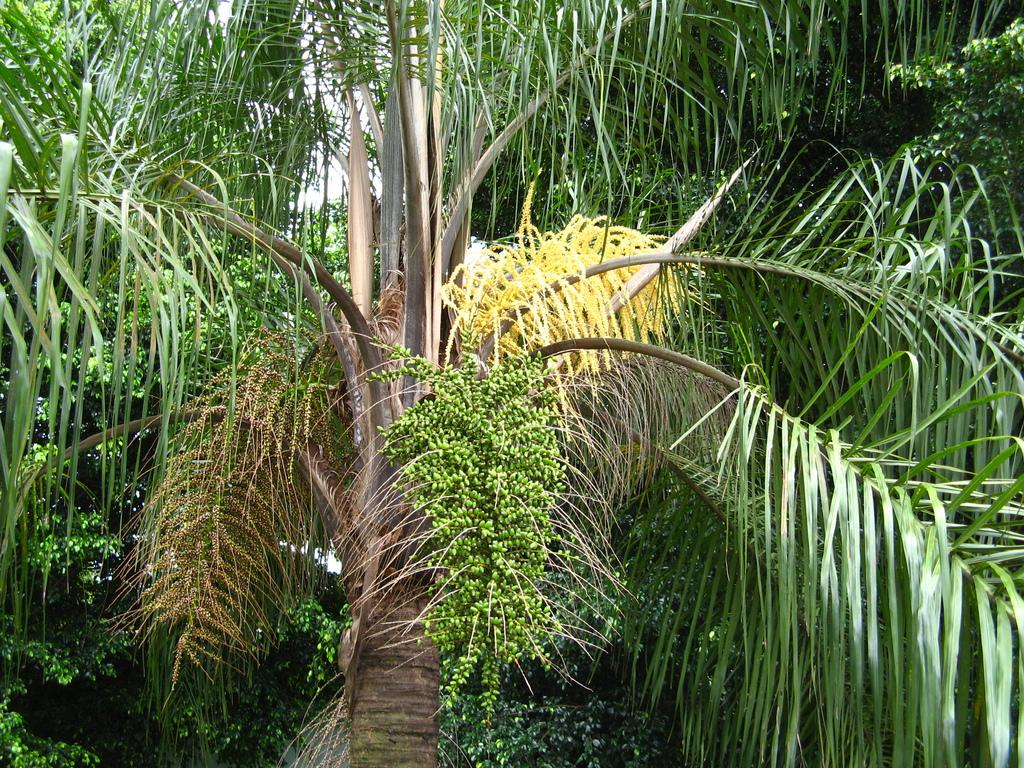What type of plant can be seen in the image? There is a tree in the image. Can you describe the background of the image? There are trees visible in the background of the image. Reasoning: Let'ing: Let's think step by step in order to produce the conversation. We start by identifying the main subject in the image, which is the tree. Then, we expand the conversation to include the background, which also features trees. Each question is designed to elicit a specific detail about the image that is known from the provided facts. Absurd Question/Answer: What type of songs can be heard coming from the tree in the image? There are no songs present in the image, as trees do not produce or play music. 